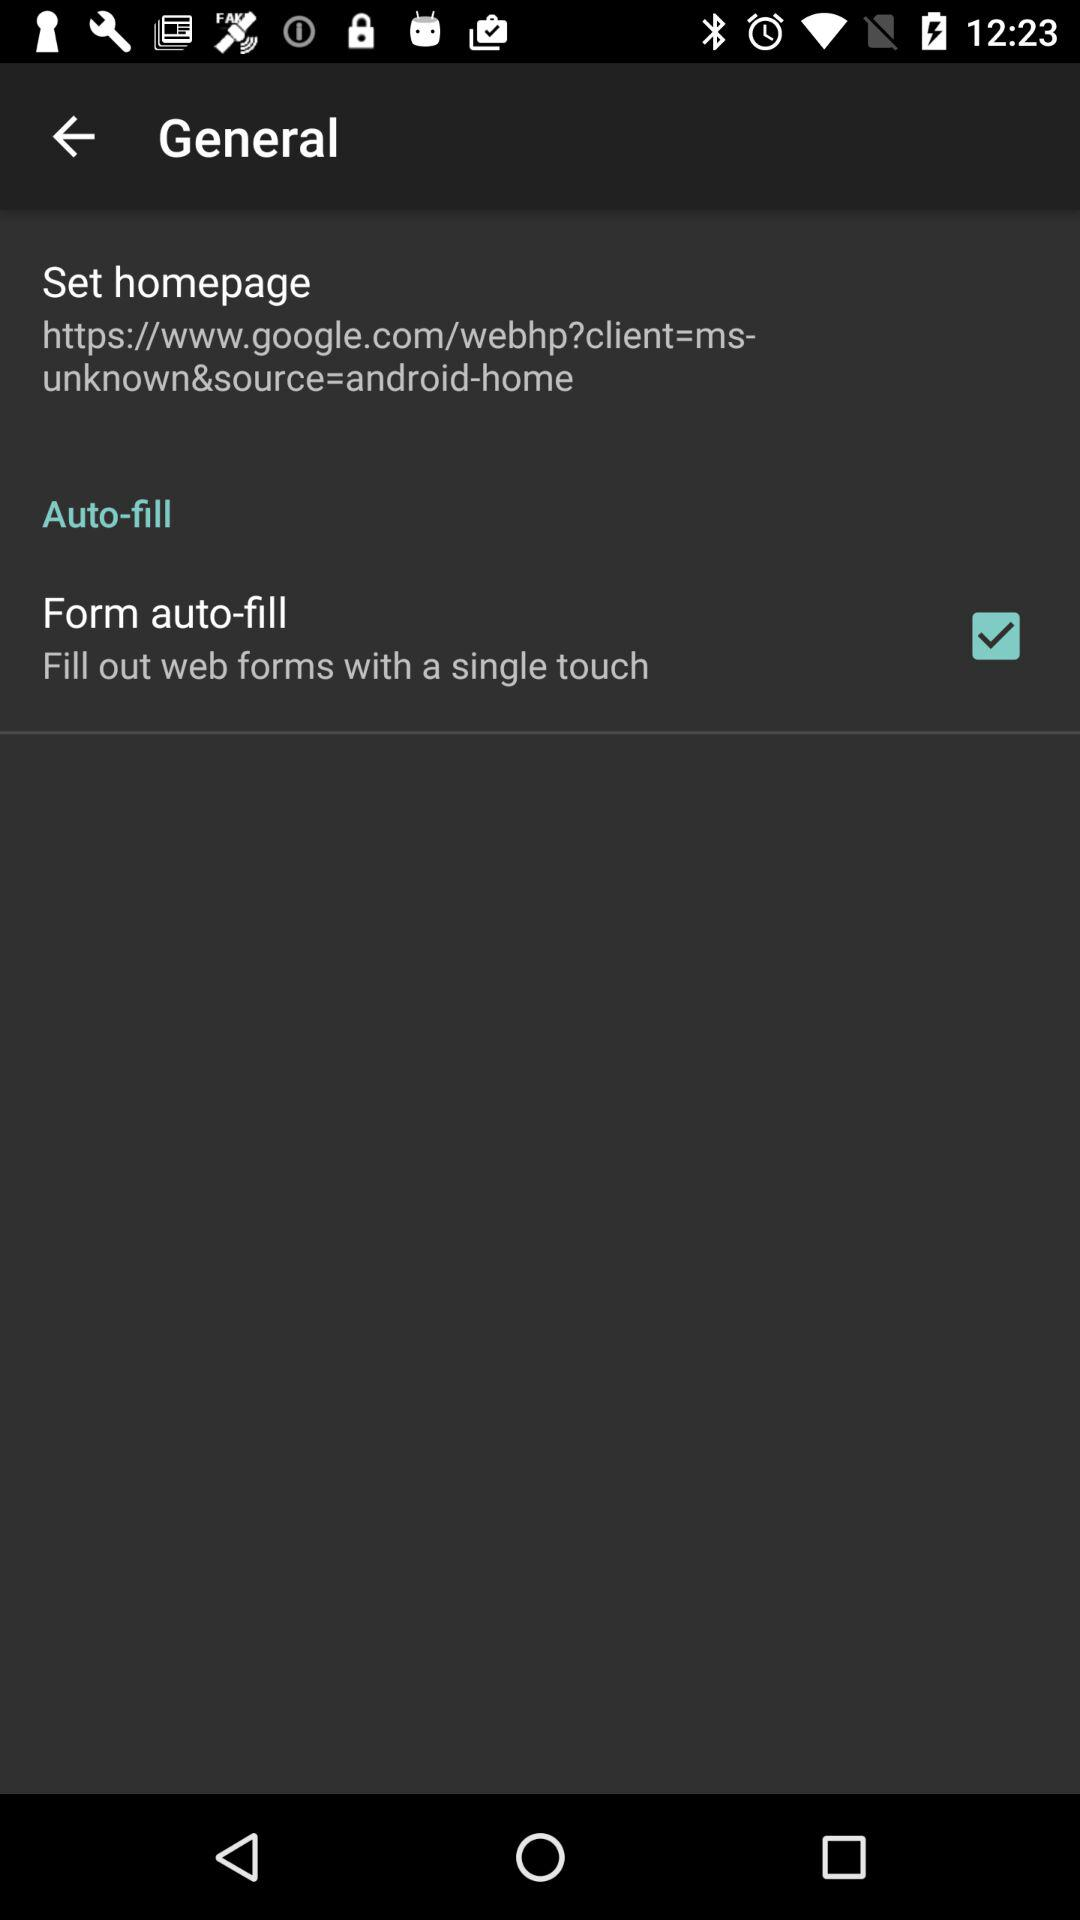What is the status of the form auto-fill? The status is on. 